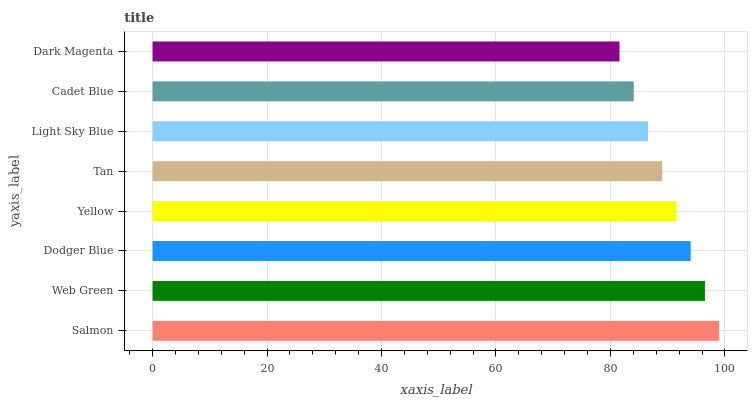Is Dark Magenta the minimum?
Answer yes or no. Yes. Is Salmon the maximum?
Answer yes or no. Yes. Is Web Green the minimum?
Answer yes or no. No. Is Web Green the maximum?
Answer yes or no. No. Is Salmon greater than Web Green?
Answer yes or no. Yes. Is Web Green less than Salmon?
Answer yes or no. Yes. Is Web Green greater than Salmon?
Answer yes or no. No. Is Salmon less than Web Green?
Answer yes or no. No. Is Yellow the high median?
Answer yes or no. Yes. Is Tan the low median?
Answer yes or no. Yes. Is Salmon the high median?
Answer yes or no. No. Is Dark Magenta the low median?
Answer yes or no. No. 